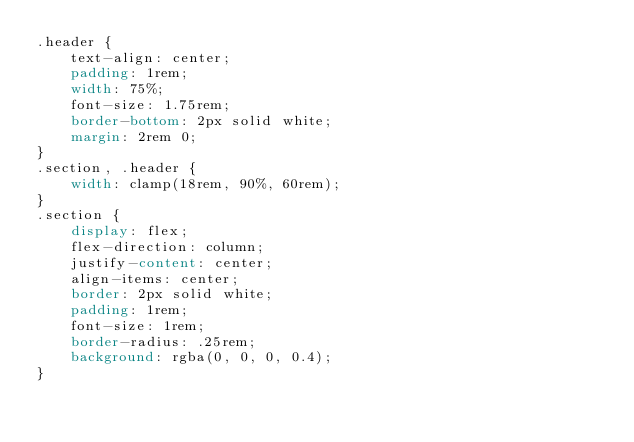Convert code to text. <code><loc_0><loc_0><loc_500><loc_500><_CSS_>.header {
    text-align: center;
    padding: 1rem;
    width: 75%;
    font-size: 1.75rem;
    border-bottom: 2px solid white;
    margin: 2rem 0;
}
.section, .header {
    width: clamp(18rem, 90%, 60rem);
}
.section {
    display: flex;
    flex-direction: column;
    justify-content: center;
    align-items: center;
    border: 2px solid white;
    padding: 1rem;
    font-size: 1rem;
    border-radius: .25rem;
    background: rgba(0, 0, 0, 0.4);
}</code> 